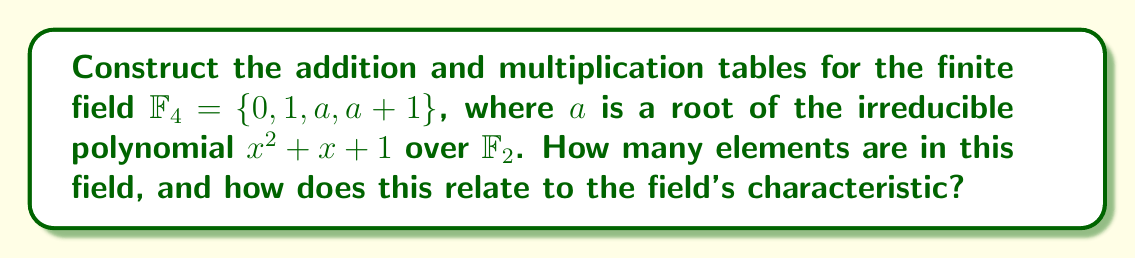Can you solve this math problem? Let's approach this step-by-step:

1) First, we need to understand what $\mathbb{F}_4$ is:
   - It's a finite field with 4 elements: $\{0, 1, a, a+1\}$
   - $a$ is a root of $x^2 + x + 1$ over $\mathbb{F}_2$, so $a^2 + a + 1 = 0$

2) Addition table:
   - Addition in $\mathbb{F}_4$ is performed modulo 2
   - $0 + x = x$ for all $x$
   - $1 + 1 = 0$
   - $a + a = 0$
   - $(a+1) + (a+1) = 0$
   - $1 + a = a + 1$

   $$
   \begin{array}{c|cccc}
   + & 0 & 1 & a & a+1 \\
   \hline
   0 & 0 & 1 & a & a+1 \\
   1 & 1 & 0 & a+1 & a \\
   a & a & a+1 & 0 & 1 \\
   a+1 & a+1 & a & 1 & 0
   \end{array}
   $$

3) Multiplication table:
   - Multiplication in $\mathbb{F}_4$ uses the fact that $a^2 = a + 1$
   - $0 \cdot x = 0$ for all $x$
   - $1 \cdot x = x$ for all $x$
   - $a \cdot a = a^2 = a + 1$
   - $a \cdot (a+1) = a^2 + a = (a+1) + a = 1$
   - $(a+1) \cdot (a+1) = a^2 + 2a + 1 = (a+1) + 1 = a$

   $$
   \begin{array}{c|cccc}
   \cdot & 0 & 1 & a & a+1 \\
   \hline
   0 & 0 & 0 & 0 & 0 \\
   1 & 0 & 1 & a & a+1 \\
   a & 0 & a & a+1 & 1 \\
   a+1 & 0 & a+1 & 1 & a
   \end{array}
   $$

4) Number of elements:
   - $\mathbb{F}_4$ has 4 elements

5) Relation to characteristic:
   - The characteristic of a field is the smallest positive integer $n$ such that $n \cdot 1 = 0$
   - In $\mathbb{F}_4$, $1 + 1 = 0$, so the characteristic is 2
   - The number of elements in $\mathbb{F}_4$ is $2^2 = 4$, which is the characteristic raised to the power of the degree of the irreducible polynomial used to construct the field
Answer: 4 elements; number of elements = characteristic^2 